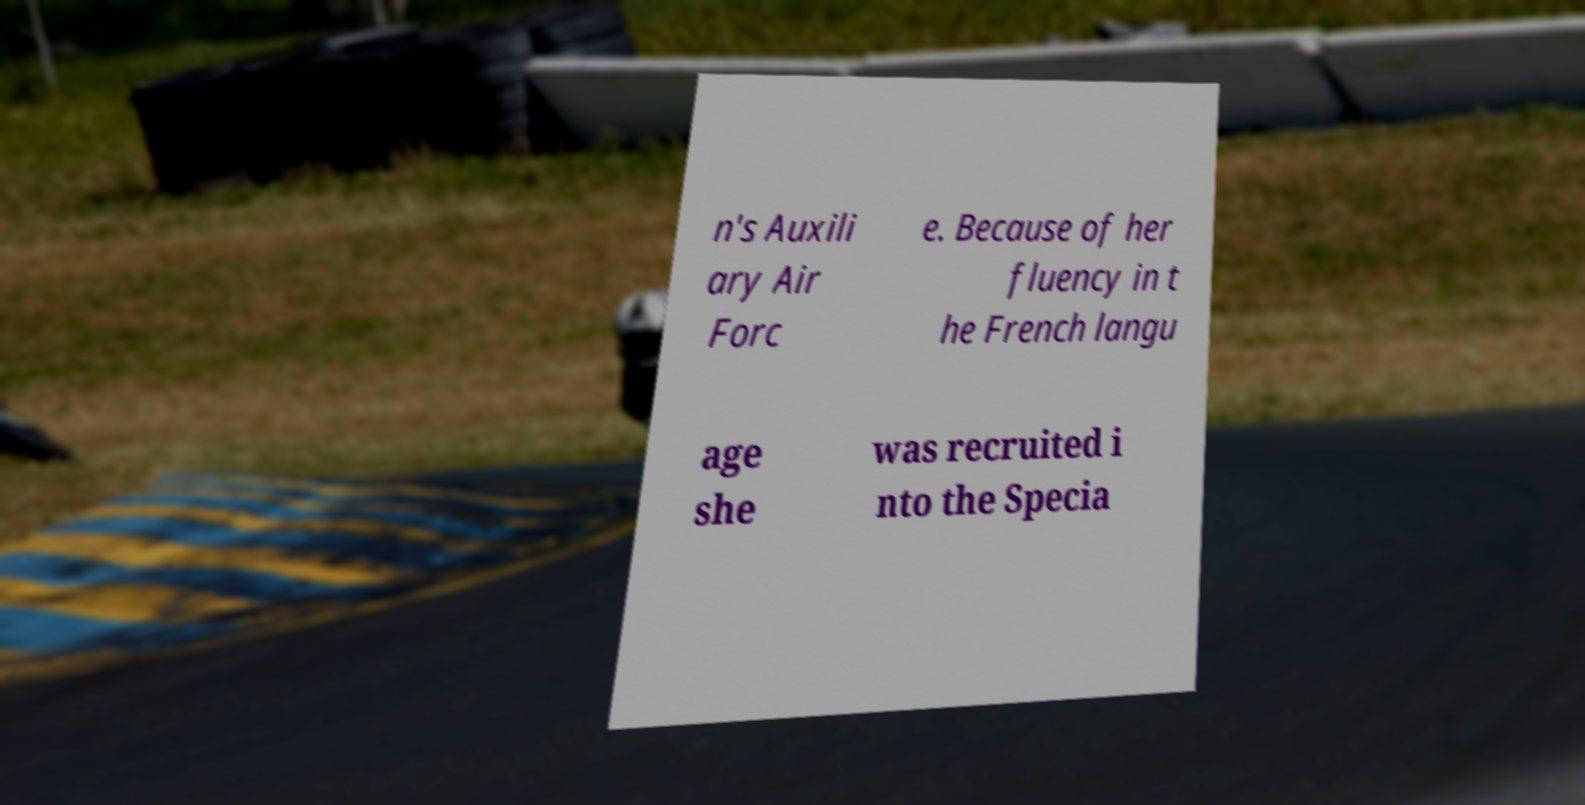Could you assist in decoding the text presented in this image and type it out clearly? n's Auxili ary Air Forc e. Because of her fluency in t he French langu age she was recruited i nto the Specia 